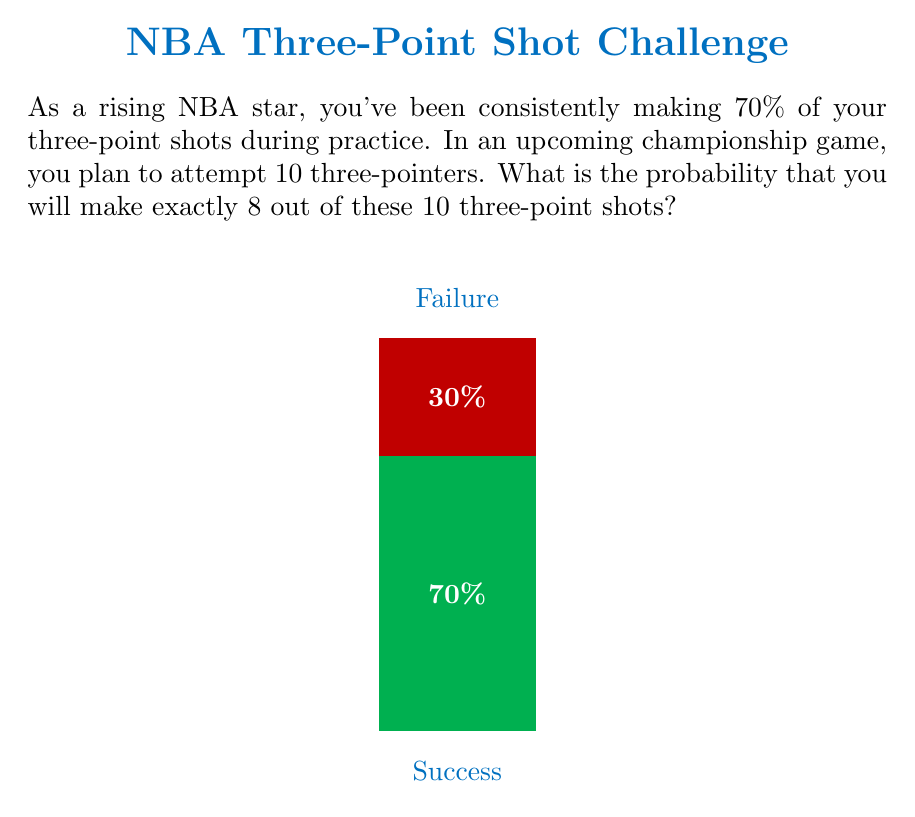Show me your answer to this math problem. To solve this problem, we'll use the binomial probability formula:

$$P(X = k) = \binom{n}{k} p^k (1-p)^{n-k}$$

Where:
- $n$ is the number of trials (10 three-point attempts)
- $k$ is the number of successes (8 successful shots)
- $p$ is the probability of success on each trial (70% or 0.7)

Step 1: Calculate $\binom{n}{k}$
$$\binom{10}{8} = \frac{10!}{8!(10-8)!} = \frac{10!}{8!2!} = 45$$

Step 2: Calculate $p^k$
$$0.7^8 = 0.0576$$

Step 3: Calculate $(1-p)^{n-k}$
$$(1-0.7)^{10-8} = 0.3^2 = 0.09$$

Step 4: Multiply all parts together
$$P(X = 8) = 45 \times 0.0576 \times 0.09 = 0.2333$$

Therefore, the probability of making exactly 8 out of 10 three-point shots is approximately 0.2333 or 23.33%.
Answer: $0.2333$ or $23.33\%$ 